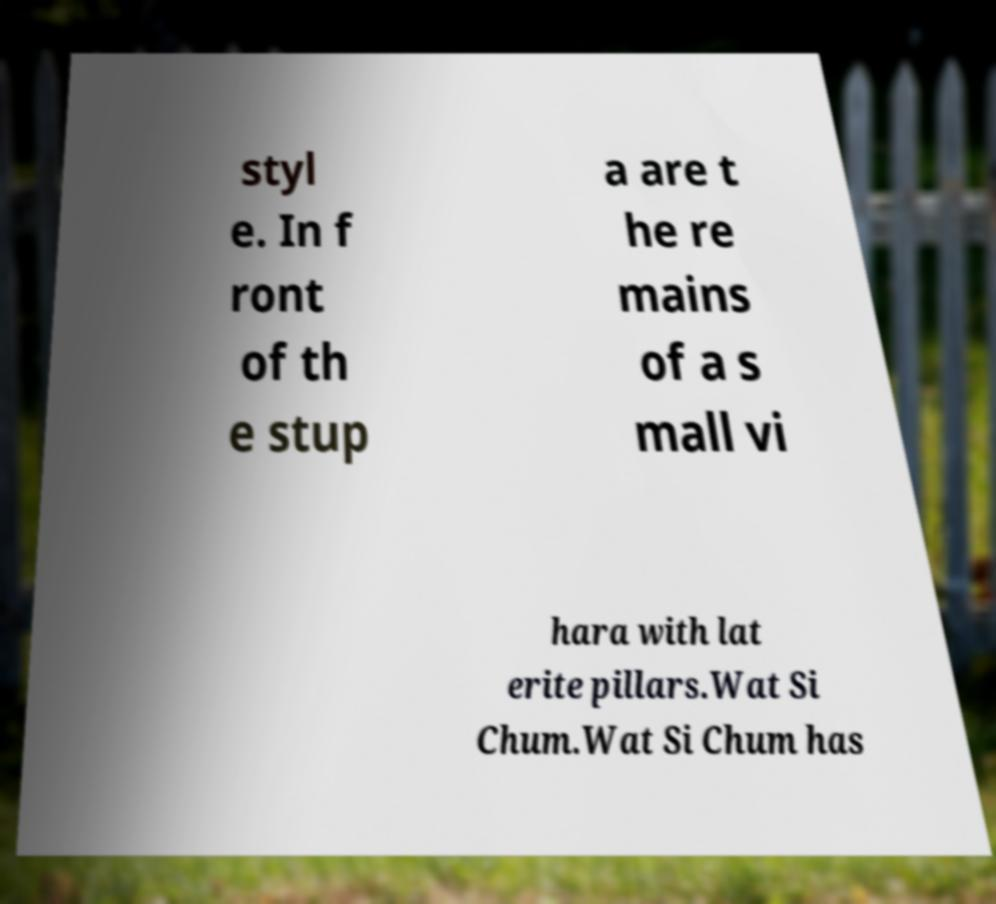There's text embedded in this image that I need extracted. Can you transcribe it verbatim? styl e. In f ront of th e stup a are t he re mains of a s mall vi hara with lat erite pillars.Wat Si Chum.Wat Si Chum has 